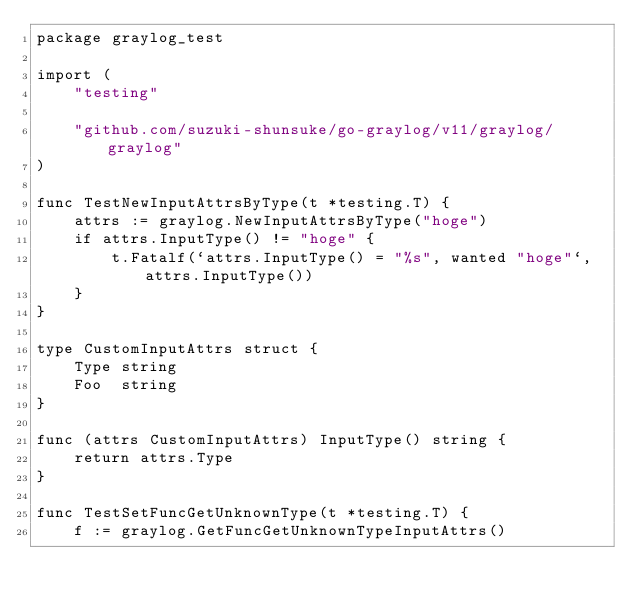Convert code to text. <code><loc_0><loc_0><loc_500><loc_500><_Go_>package graylog_test

import (
	"testing"

	"github.com/suzuki-shunsuke/go-graylog/v11/graylog/graylog"
)

func TestNewInputAttrsByType(t *testing.T) {
	attrs := graylog.NewInputAttrsByType("hoge")
	if attrs.InputType() != "hoge" {
		t.Fatalf(`attrs.InputType() = "%s", wanted "hoge"`, attrs.InputType())
	}
}

type CustomInputAttrs struct {
	Type string
	Foo  string
}

func (attrs CustomInputAttrs) InputType() string {
	return attrs.Type
}

func TestSetFuncGetUnknownType(t *testing.T) {
	f := graylog.GetFuncGetUnknownTypeInputAttrs()</code> 